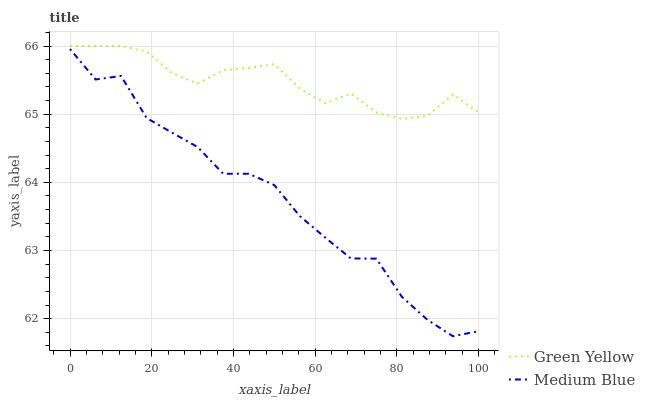Does Medium Blue have the minimum area under the curve?
Answer yes or no. Yes. Does Green Yellow have the maximum area under the curve?
Answer yes or no. Yes. Does Medium Blue have the maximum area under the curve?
Answer yes or no. No. Is Green Yellow the smoothest?
Answer yes or no. Yes. Is Medium Blue the roughest?
Answer yes or no. Yes. Is Medium Blue the smoothest?
Answer yes or no. No. Does Medium Blue have the lowest value?
Answer yes or no. Yes. Does Green Yellow have the highest value?
Answer yes or no. Yes. Does Medium Blue have the highest value?
Answer yes or no. No. Is Medium Blue less than Green Yellow?
Answer yes or no. Yes. Is Green Yellow greater than Medium Blue?
Answer yes or no. Yes. Does Medium Blue intersect Green Yellow?
Answer yes or no. No. 